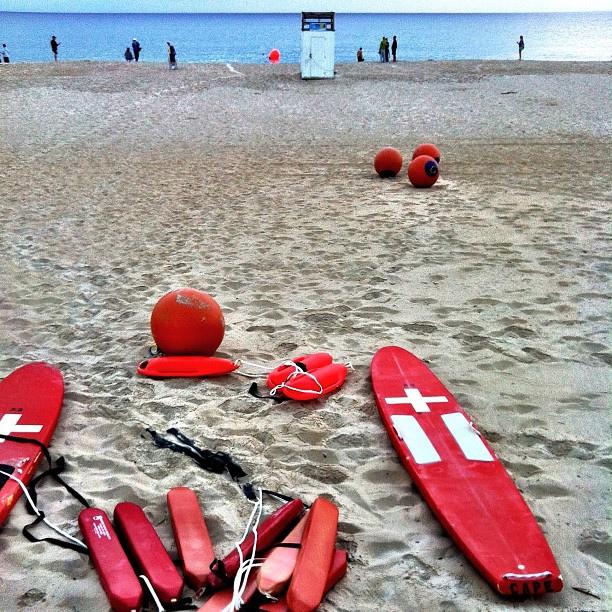What are the small items in the middle used for?
Give a very brief answer. Lifesaving. Where did the lifeguards go?
Concise answer only. Ocean. See footprints in the sand?
Keep it brief. Yes. 